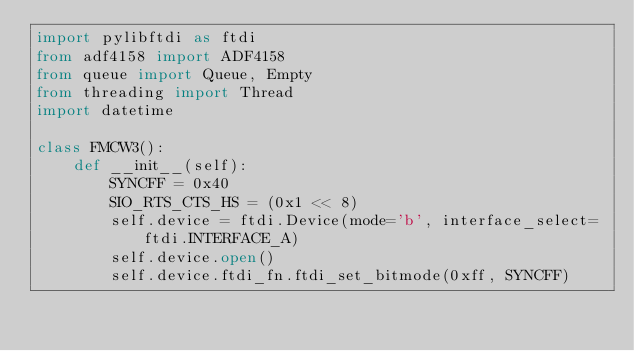Convert code to text. <code><loc_0><loc_0><loc_500><loc_500><_Python_>import pylibftdi as ftdi
from adf4158 import ADF4158
from queue import Queue, Empty
from threading import Thread
import datetime

class FMCW3():
    def __init__(self):
        SYNCFF = 0x40
        SIO_RTS_CTS_HS = (0x1 << 8)
        self.device = ftdi.Device(mode='b', interface_select=ftdi.INTERFACE_A)
        self.device.open()
        self.device.ftdi_fn.ftdi_set_bitmode(0xff, SYNCFF)</code> 